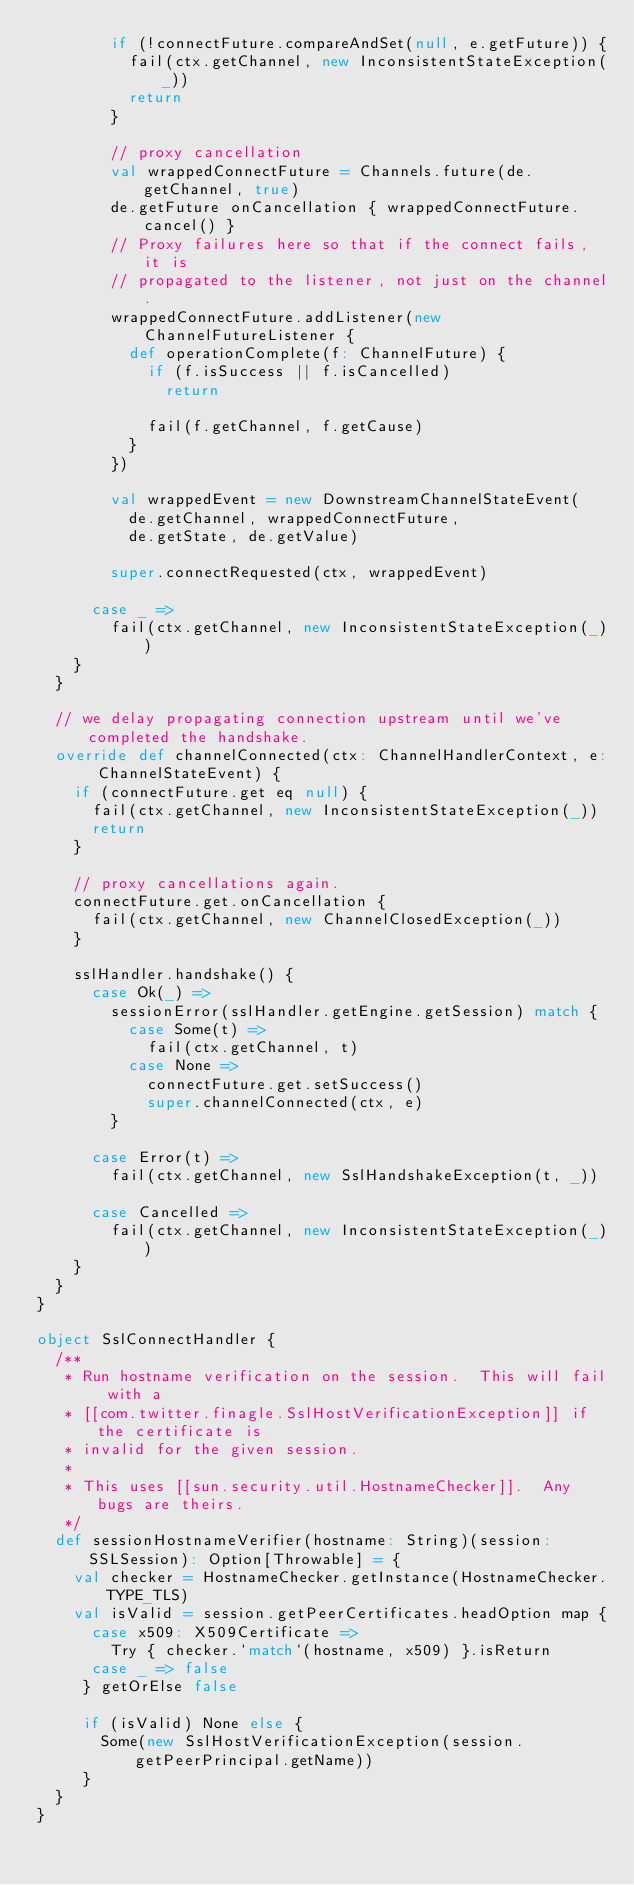Convert code to text. <code><loc_0><loc_0><loc_500><loc_500><_Scala_>        if (!connectFuture.compareAndSet(null, e.getFuture)) {
          fail(ctx.getChannel, new InconsistentStateException(_))
          return
        }

        // proxy cancellation
        val wrappedConnectFuture = Channels.future(de.getChannel, true)
        de.getFuture onCancellation { wrappedConnectFuture.cancel() }
        // Proxy failures here so that if the connect fails, it is
        // propagated to the listener, not just on the channel.
        wrappedConnectFuture.addListener(new ChannelFutureListener {
          def operationComplete(f: ChannelFuture) {
            if (f.isSuccess || f.isCancelled)
              return

            fail(f.getChannel, f.getCause)
          }
        })

        val wrappedEvent = new DownstreamChannelStateEvent(
          de.getChannel, wrappedConnectFuture,
          de.getState, de.getValue)

        super.connectRequested(ctx, wrappedEvent)

      case _ =>
        fail(ctx.getChannel, new InconsistentStateException(_))
    }
  }

  // we delay propagating connection upstream until we've completed the handshake.
  override def channelConnected(ctx: ChannelHandlerContext, e: ChannelStateEvent) {
    if (connectFuture.get eq null) {
      fail(ctx.getChannel, new InconsistentStateException(_))
      return
    }

    // proxy cancellations again.
    connectFuture.get.onCancellation {
      fail(ctx.getChannel, new ChannelClosedException(_))
    }

    sslHandler.handshake() {
      case Ok(_) =>
        sessionError(sslHandler.getEngine.getSession) match {
          case Some(t) =>
            fail(ctx.getChannel, t)
          case None =>
            connectFuture.get.setSuccess()
            super.channelConnected(ctx, e)
        }

      case Error(t) =>
        fail(ctx.getChannel, new SslHandshakeException(t, _))

      case Cancelled =>
        fail(ctx.getChannel, new InconsistentStateException(_))
    }
  }
}

object SslConnectHandler {
  /**
   * Run hostname verification on the session.  This will fail with a
   * [[com.twitter.finagle.SslHostVerificationException]] if the certificate is
   * invalid for the given session.
   *
   * This uses [[sun.security.util.HostnameChecker]].  Any bugs are theirs.
   */
  def sessionHostnameVerifier(hostname: String)(session: SSLSession): Option[Throwable] = {
    val checker = HostnameChecker.getInstance(HostnameChecker.TYPE_TLS)
    val isValid = session.getPeerCertificates.headOption map {
      case x509: X509Certificate =>
        Try { checker.`match`(hostname, x509) }.isReturn
      case _ => false
     } getOrElse false

     if (isValid) None else {
       Some(new SslHostVerificationException(session.getPeerPrincipal.getName))
     }
  }
}
</code> 